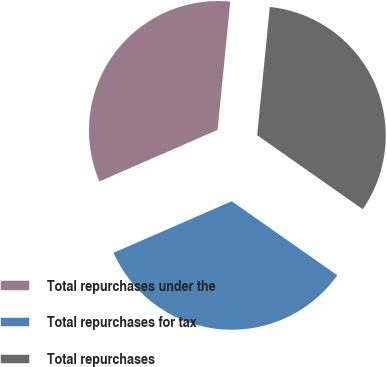Convert chart. <chart><loc_0><loc_0><loc_500><loc_500><pie_chart><fcel>Total repurchases under the<fcel>Total repurchases for tax<fcel>Total repurchases<nl><fcel>33.11%<fcel>33.72%<fcel>33.17%<nl></chart> 